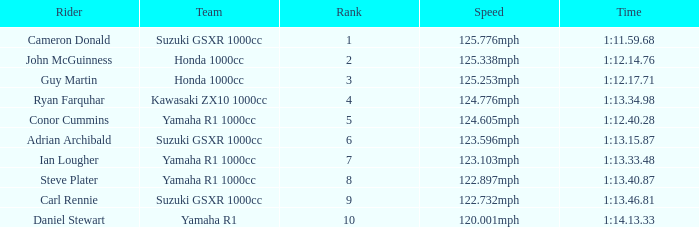What is the rank for the team with a Time of 1:12.40.28? 5.0. 